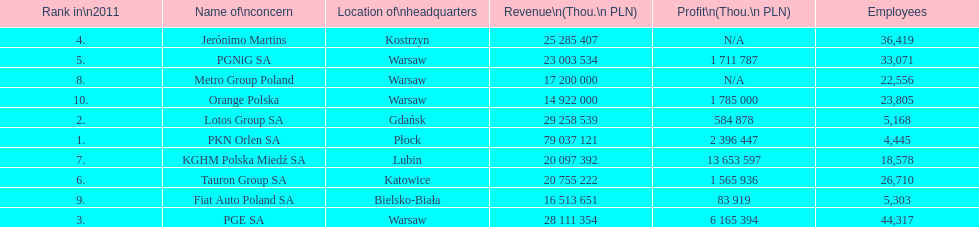What is the number of employees who work for pgnig sa? 33,071. 